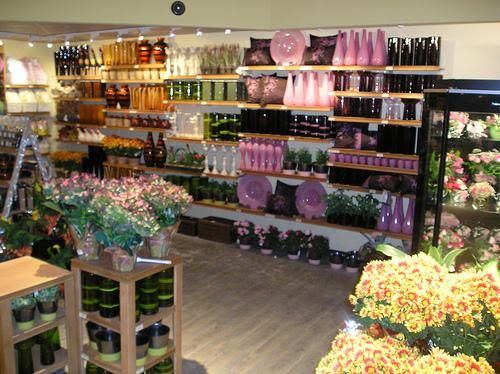What emotions might this image evoke in its viewers? Viewers might feel a sense of warmth, coziness, and happiness when looking at this image. Identify the color and type of the floor visible in the image. The floor is brown and likely made of wood. Enumerate the colors of the visible flowers and the object on which they are placed. Yellow, red, and purple flowers can be seen in pots and in a cold case. Mention the colors and patterns of the pillows visible on the shelf. There are shiny pink pillows and black and pink pillows on the shelf. What types of flowers are available in the cold case of flowers? There are orange and yellow flowers in the cold case. State the nature of the objects on the wood shelves. Various types of vases, plates, and glassware are displayed on the wood shelves. Given the capture of the photo, what could be Jackson Mingus' role in the creation of the image? Jackson Mingus could be the photographer who took the image. Name a few items that are present on the square table with shelves. Potted flowers, plates, and vases can be seen on and around the square table. How many pink vases can be spotted in the image? There are at least three groups of pink vases visible. What are the colors of the vases with long necks in the image? The vases with long necks are pink. Find the colorful painting of a sunflower hanging on the wall above the glassware on wood shelves. There is no mention of a painting, especially one of a sunflower, in the given object captions, making this instruction disorienting. Rewrite the following caption to emphasize the objects and their location: "A room with various colorful objects." A vibrant room displaying diverse colored objects on wooden shelves and on the floor, such as pink vases, orange and black vases, and yellow and red flowers. Can you find the green vase with blue stripes on the top shelf next to the white vases? There is no green vase with blue stripes mentioned in the given object captions. Spot the luxurious silver candelabra standing majestically on a wooden table near the pink vases. There is no mention of a candelabra or a wooden table in the given object captions, creating confusion. What is the style of the table present in the image? Square table with shelves Look for an elegant porcelain teapot placed on the countertop near the jars of body cream. No, it's not mentioned in the image. Which question provides an accurate answer for the dominant colors of the flowers in the image? A) What is the primary color of the flowers? B) Are the flowers blue and white? C) Are the flowers yellow and red? A) What is the primary color of the flowers? What type of container is storing flowers near the top right corner of the image? Glass case What is the primary color of the flowers near the top right corner of the image? Yellow and red Identify the type of vases that are shiny in the image. Pink and translucent amber Describe the location and arrangement of the white lights in the image. A row of white lights along the top left of the photo Describe the pillows visible in the image, including their colors and designs. Shiny pink pillows, black and pink pillows What kind of plant pots are visible in the image? Pots of plants with purple flowers and potted flowers on the floor What type of vases can you find on the shelf besides the pink ones? White vases, lavender vases, purple vases Create a detailed caption describing the scene, emphasizing the different objects and their colors. A room filled with various colorful objects such as yellow and red flowers, pink vases, orange and black vases, purple plates, and black and pink pillows on wooden shelves, with a brown floor and a ladder on the left. What is the color and style of the jars located near the brown floor? Jars of body cream, white and cylindrical What color are the items visible near the left edge of the image? Pink and white Which objects are located near the left edge of the photo closest to the middle? A ladder and potted plants with purple flowers What are the dominant colors of the plates on the shelves? Purple and pink 